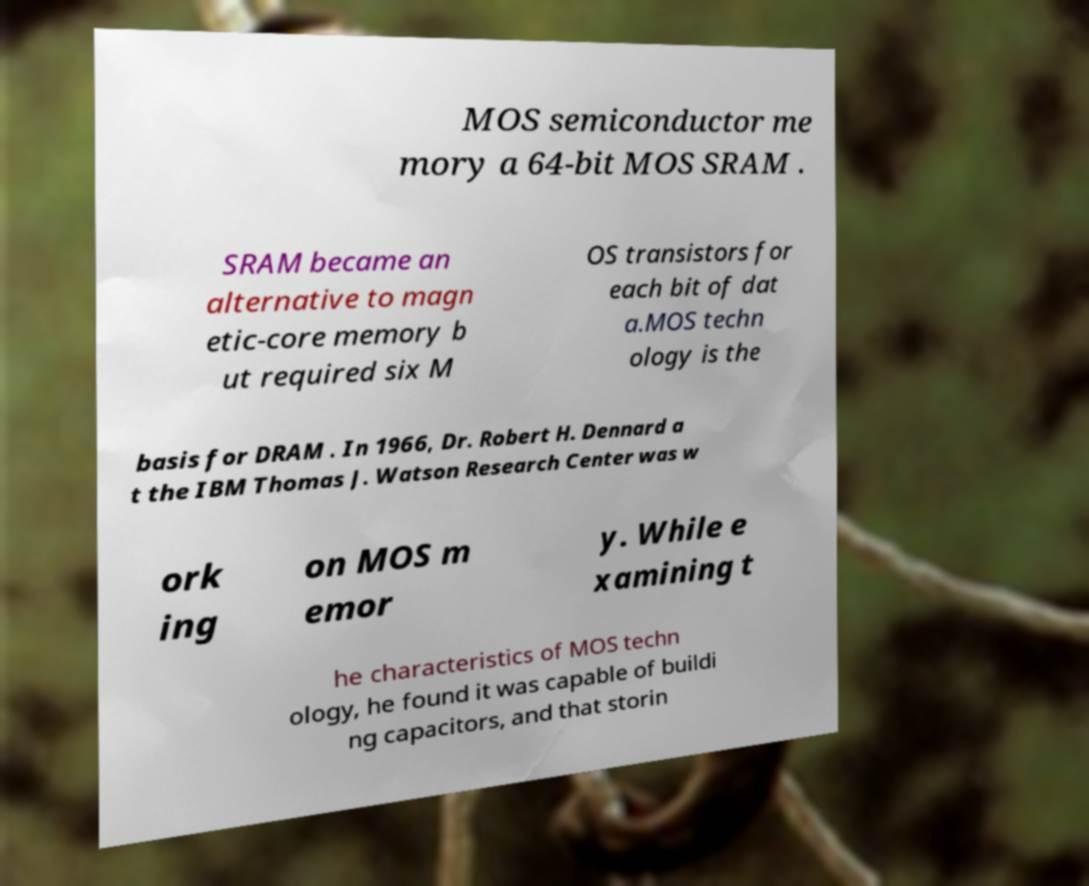For documentation purposes, I need the text within this image transcribed. Could you provide that? MOS semiconductor me mory a 64-bit MOS SRAM . SRAM became an alternative to magn etic-core memory b ut required six M OS transistors for each bit of dat a.MOS techn ology is the basis for DRAM . In 1966, Dr. Robert H. Dennard a t the IBM Thomas J. Watson Research Center was w ork ing on MOS m emor y. While e xamining t he characteristics of MOS techn ology, he found it was capable of buildi ng capacitors, and that storin 